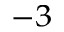<formula> <loc_0><loc_0><loc_500><loc_500>^ { - 3 }</formula> 